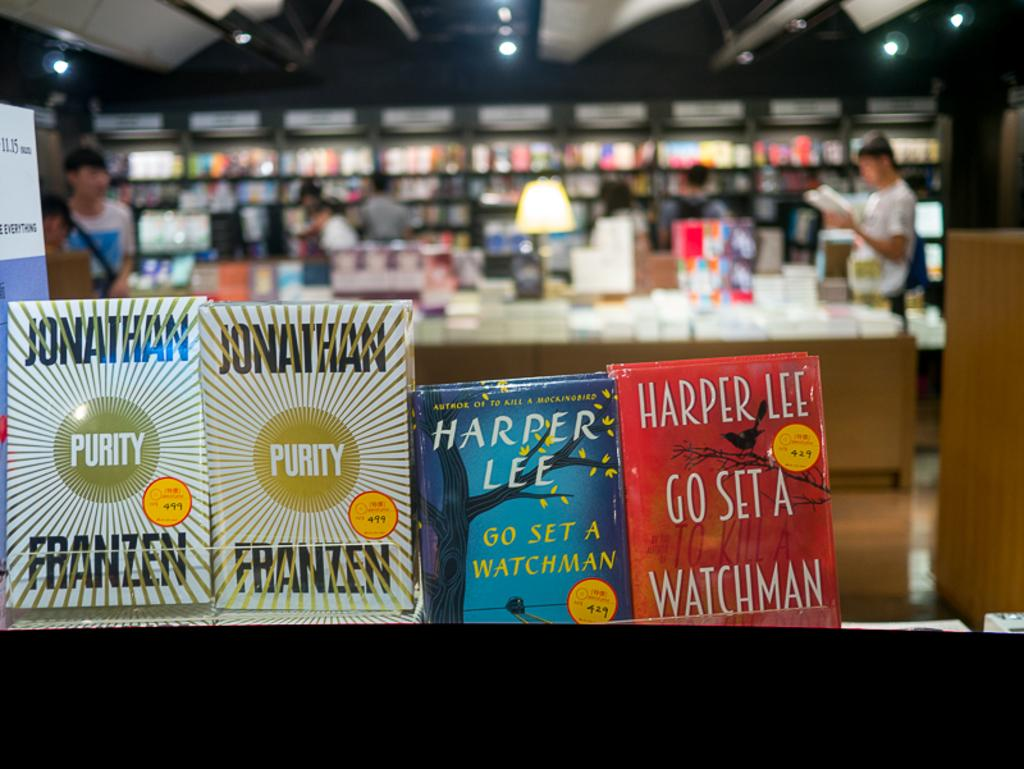<image>
Offer a succinct explanation of the picture presented. books in a bookshop including Purity and Harper Lee 